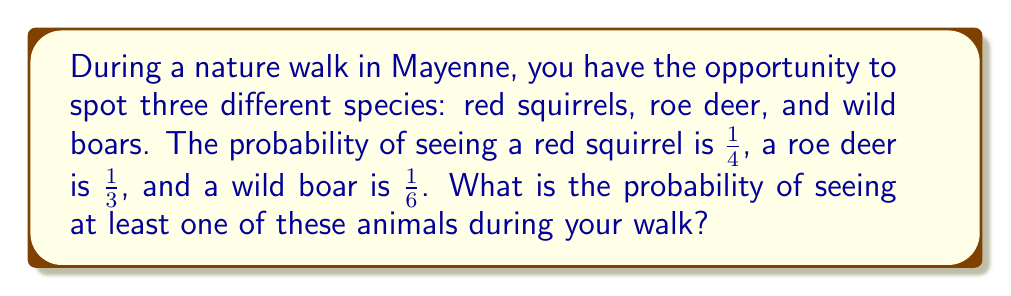Can you solve this math problem? Let's approach this step-by-step using the concept of complementary events:

1) First, let's define our events:
   $R$: Seeing a red squirrel
   $D$: Seeing a roe deer
   $B$: Seeing a wild boar

2) We're asked to find the probability of seeing at least one of these animals. This is equivalent to 1 minus the probability of seeing none of them.

3) Probability of seeing none:
   $P(\text{none}) = P(\text{not }R \text{ and not }D \text{ and not }B)$

4) Since these events are independent:
   $P(\text{none}) = P(\text{not }R) \cdot P(\text{not }D) \cdot P(\text{not }B)$

5) We can calculate each of these:
   $P(\text{not }R) = 1 - P(R) = 1 - \frac{1}{4} = \frac{3}{4}$
   $P(\text{not }D) = 1 - P(D) = 1 - \frac{1}{3} = \frac{2}{3}$
   $P(\text{not }B) = 1 - P(B) = 1 - \frac{1}{6} = \frac{5}{6}$

6) Now we can multiply these:
   $P(\text{none}) = \frac{3}{4} \cdot \frac{2}{3} \cdot \frac{5}{6} = \frac{30}{72} = \frac{5}{12}$

7) Finally, the probability of seeing at least one is:
   $P(\text{at least one}) = 1 - P(\text{none}) = 1 - \frac{5}{12} = \frac{7}{12}$
Answer: $\frac{7}{12}$ 